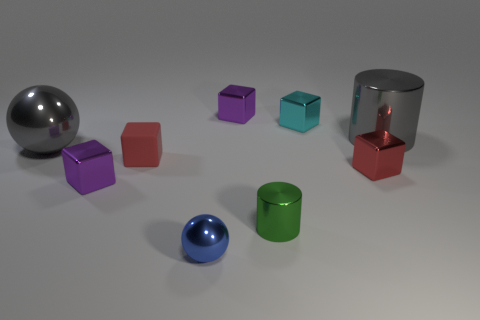What number of other things are made of the same material as the gray sphere?
Your answer should be compact. 7. Do the green cylinder and the gray ball have the same size?
Your answer should be compact. No. How many objects are either purple metal objects that are left of the green metal cylinder or big gray shiny balls?
Your response must be concise. 3. What material is the tiny red cube that is right of the metal cylinder on the left side of the small red metal cube?
Your response must be concise. Metal. Is there another small thing of the same shape as the red metallic object?
Provide a short and direct response. Yes. Does the green shiny cylinder have the same size as the cylinder behind the green object?
Provide a short and direct response. No. How many objects are either tiny metallic objects on the left side of the small blue shiny object or purple objects in front of the gray ball?
Your answer should be very brief. 1. Is the number of large gray metallic things that are to the right of the tiny red matte thing greater than the number of blue shiny blocks?
Your response must be concise. Yes. How many blue metal cubes are the same size as the cyan cube?
Your answer should be very brief. 0. There is a sphere behind the small cylinder; is it the same size as the gray thing to the right of the tiny blue thing?
Provide a short and direct response. Yes. 